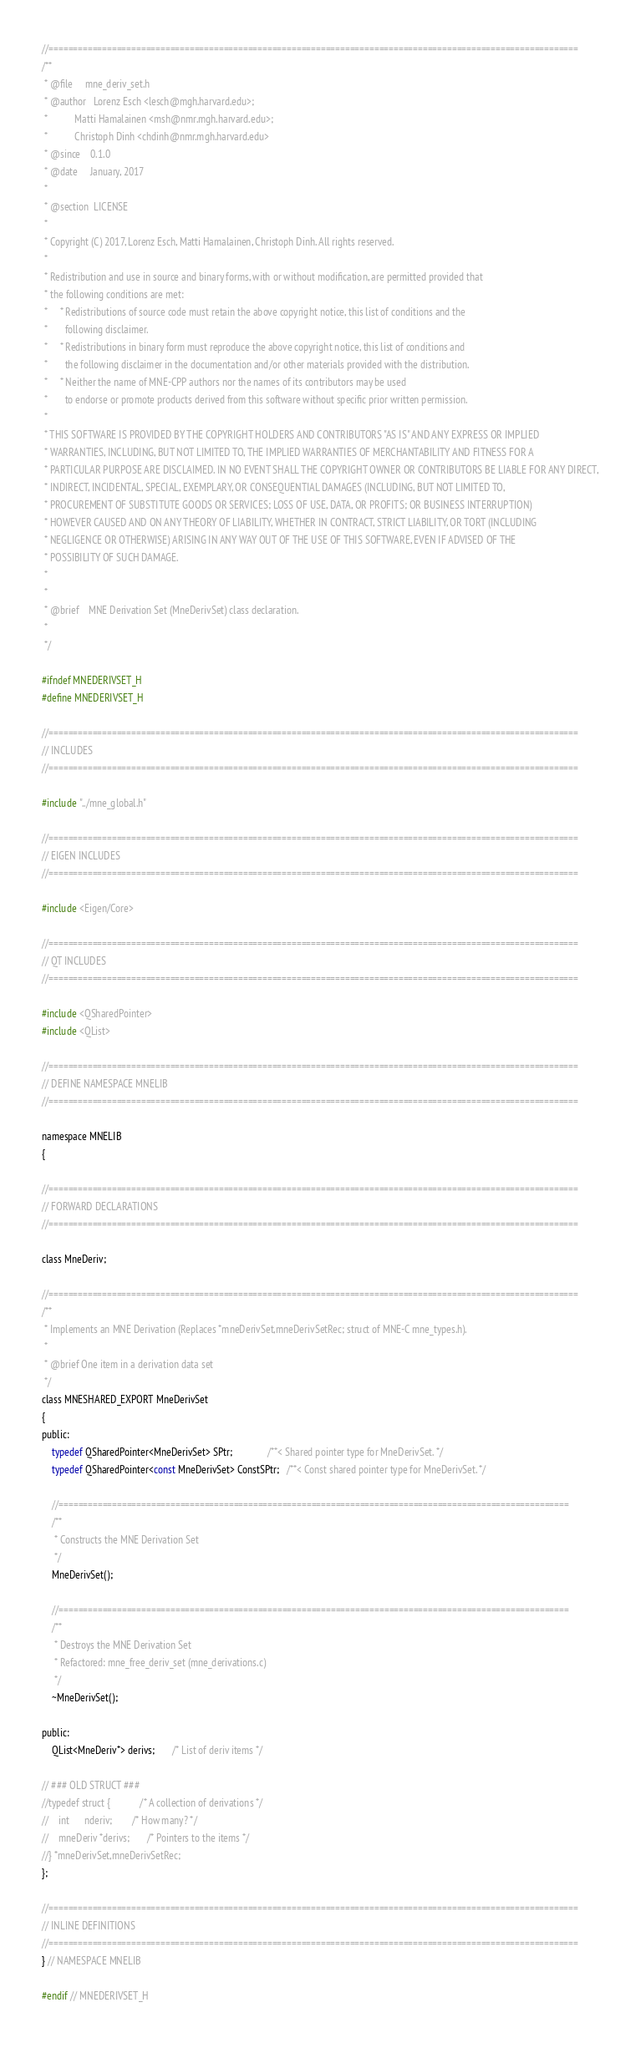Convert code to text. <code><loc_0><loc_0><loc_500><loc_500><_C_>//=============================================================================================================
/**
 * @file     mne_deriv_set.h
 * @author   Lorenz Esch <lesch@mgh.harvard.edu>;
 *           Matti Hamalainen <msh@nmr.mgh.harvard.edu>;
 *           Christoph Dinh <chdinh@nmr.mgh.harvard.edu>
 * @since    0.1.0
 * @date     January, 2017
 *
 * @section  LICENSE
 *
 * Copyright (C) 2017, Lorenz Esch, Matti Hamalainen, Christoph Dinh. All rights reserved.
 *
 * Redistribution and use in source and binary forms, with or without modification, are permitted provided that
 * the following conditions are met:
 *     * Redistributions of source code must retain the above copyright notice, this list of conditions and the
 *       following disclaimer.
 *     * Redistributions in binary form must reproduce the above copyright notice, this list of conditions and
 *       the following disclaimer in the documentation and/or other materials provided with the distribution.
 *     * Neither the name of MNE-CPP authors nor the names of its contributors may be used
 *       to endorse or promote products derived from this software without specific prior written permission.
 *
 * THIS SOFTWARE IS PROVIDED BY THE COPYRIGHT HOLDERS AND CONTRIBUTORS "AS IS" AND ANY EXPRESS OR IMPLIED
 * WARRANTIES, INCLUDING, BUT NOT LIMITED TO, THE IMPLIED WARRANTIES OF MERCHANTABILITY AND FITNESS FOR A
 * PARTICULAR PURPOSE ARE DISCLAIMED. IN NO EVENT SHALL THE COPYRIGHT OWNER OR CONTRIBUTORS BE LIABLE FOR ANY DIRECT,
 * INDIRECT, INCIDENTAL, SPECIAL, EXEMPLARY, OR CONSEQUENTIAL DAMAGES (INCLUDING, BUT NOT LIMITED TO,
 * PROCUREMENT OF SUBSTITUTE GOODS OR SERVICES; LOSS OF USE, DATA, OR PROFITS; OR BUSINESS INTERRUPTION)
 * HOWEVER CAUSED AND ON ANY THEORY OF LIABILITY, WHETHER IN CONTRACT, STRICT LIABILITY, OR TORT (INCLUDING
 * NEGLIGENCE OR OTHERWISE) ARISING IN ANY WAY OUT OF THE USE OF THIS SOFTWARE, EVEN IF ADVISED OF THE
 * POSSIBILITY OF SUCH DAMAGE.
 *
 *
 * @brief    MNE Derivation Set (MneDerivSet) class declaration.
 *
 */

#ifndef MNEDERIVSET_H
#define MNEDERIVSET_H

//=============================================================================================================
// INCLUDES
//=============================================================================================================

#include "../mne_global.h"

//=============================================================================================================
// EIGEN INCLUDES
//=============================================================================================================

#include <Eigen/Core>

//=============================================================================================================
// QT INCLUDES
//=============================================================================================================

#include <QSharedPointer>
#include <QList>

//=============================================================================================================
// DEFINE NAMESPACE MNELIB
//=============================================================================================================

namespace MNELIB
{

//=============================================================================================================
// FORWARD DECLARATIONS
//=============================================================================================================

class MneDeriv;

//=============================================================================================================
/**
 * Implements an MNE Derivation (Replaces *mneDerivSet,mneDerivSetRec; struct of MNE-C mne_types.h).
 *
 * @brief One item in a derivation data set
 */
class MNESHARED_EXPORT MneDerivSet
{
public:
    typedef QSharedPointer<MneDerivSet> SPtr;              /**< Shared pointer type for MneDerivSet. */
    typedef QSharedPointer<const MneDerivSet> ConstSPtr;   /**< Const shared pointer type for MneDerivSet. */

    //=========================================================================================================
    /**
     * Constructs the MNE Derivation Set
     */
    MneDerivSet();

    //=========================================================================================================
    /**
     * Destroys the MNE Derivation Set
     * Refactored: mne_free_deriv_set (mne_derivations.c)
     */
    ~MneDerivSet();

public:
    QList<MneDeriv*> derivs;       /* List of deriv items */

// ### OLD STRUCT ###
//typedef struct {            /* A collection of derivations */
//    int      nderiv;        /* How many? */
//    mneDeriv *derivs;       /* Pointers to the items */
//} *mneDerivSet,mneDerivSetRec;
};

//=============================================================================================================
// INLINE DEFINITIONS
//=============================================================================================================
} // NAMESPACE MNELIB

#endif // MNEDERIVSET_H
</code> 